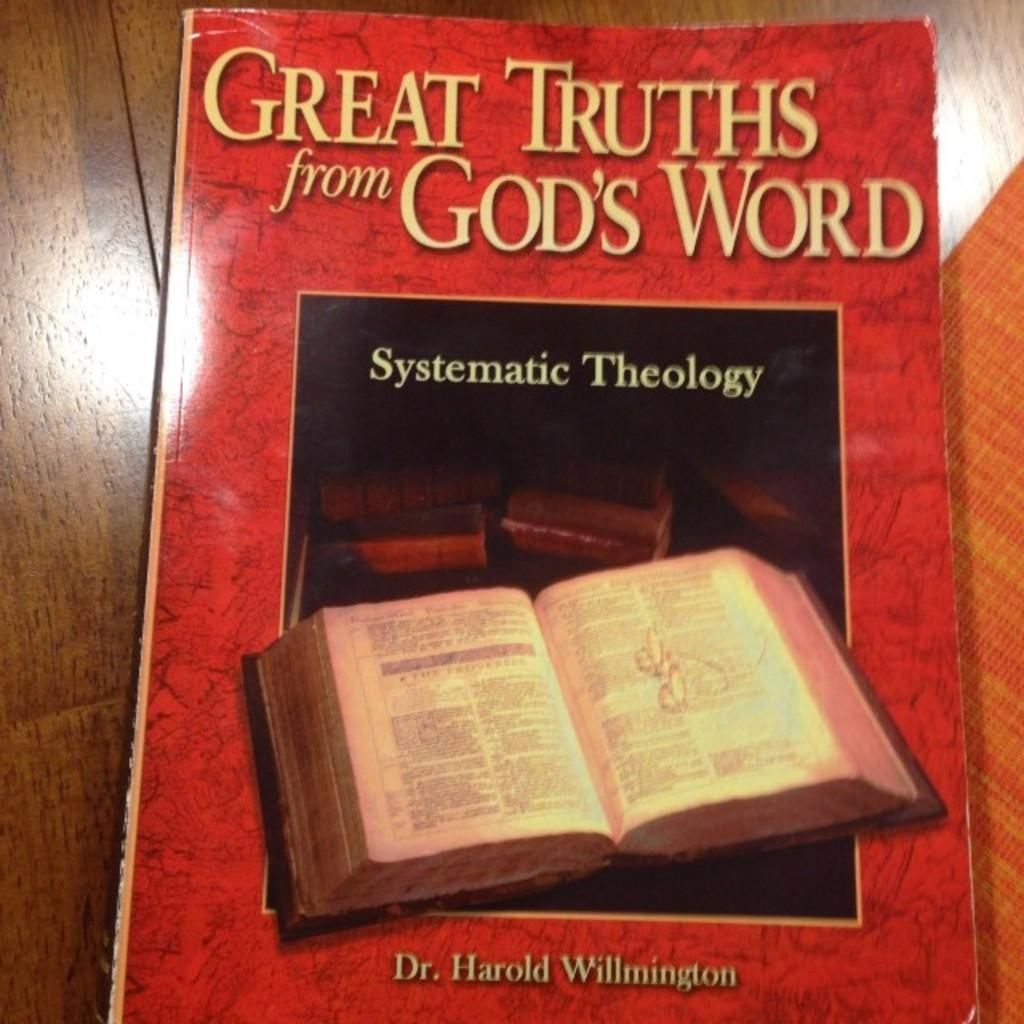<image>
Share a concise interpretation of the image provided. A book explores the religious discipline known as systematic theology. 